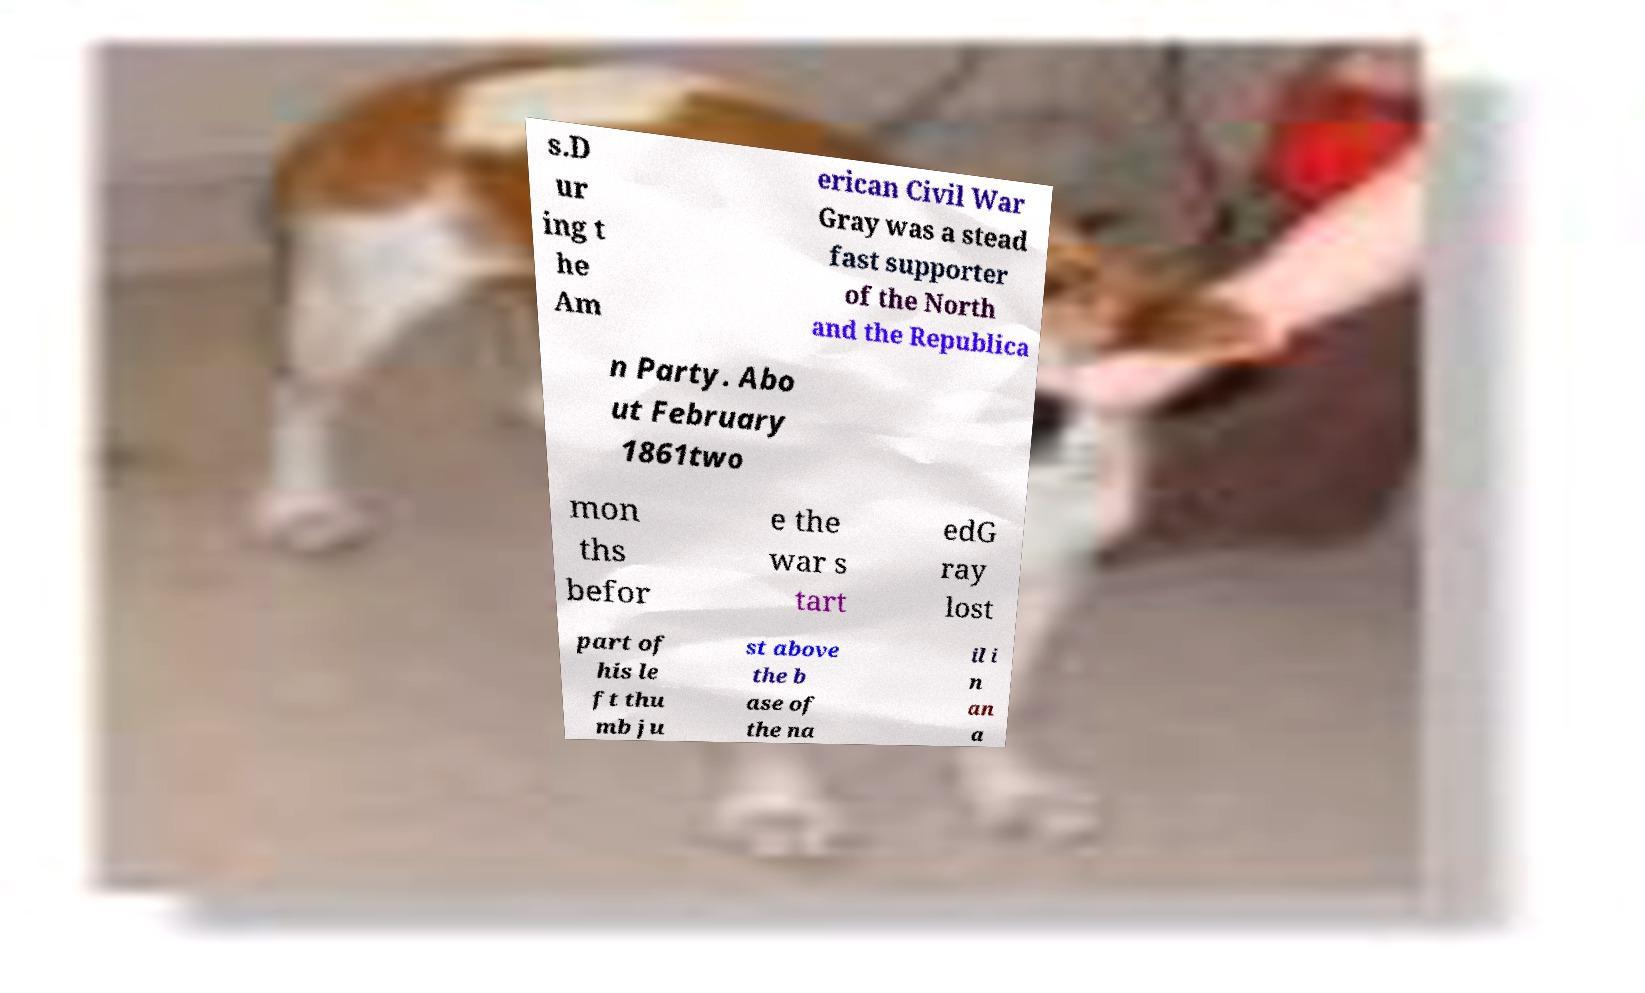Please identify and transcribe the text found in this image. s.D ur ing t he Am erican Civil War Gray was a stead fast supporter of the North and the Republica n Party. Abo ut February 1861two mon ths befor e the war s tart edG ray lost part of his le ft thu mb ju st above the b ase of the na il i n an a 